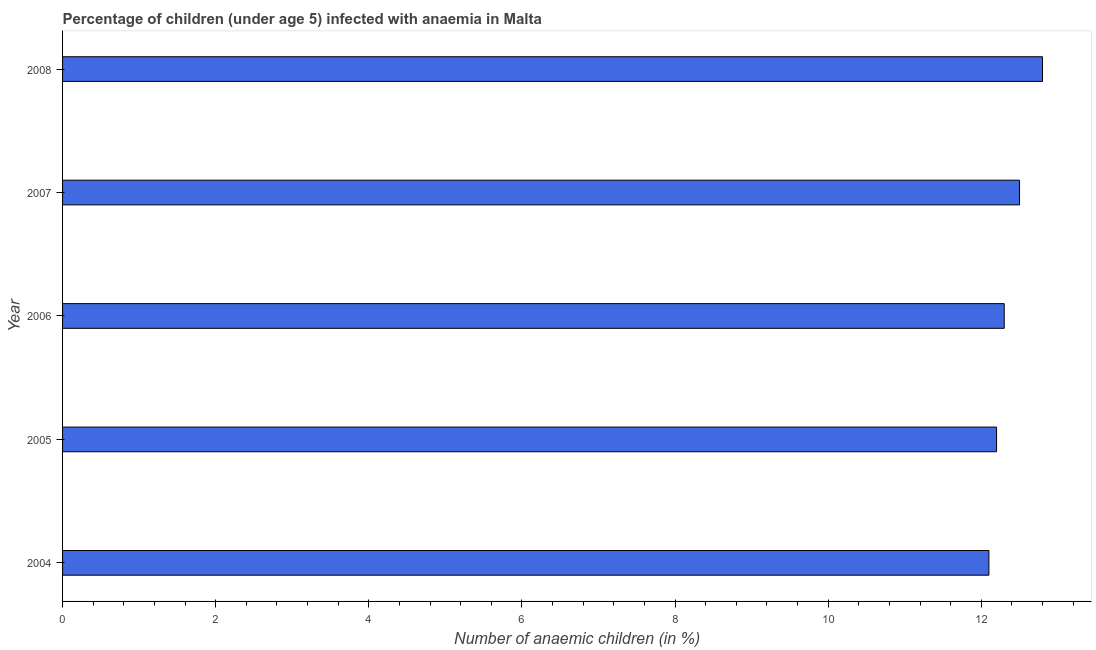What is the title of the graph?
Make the answer very short. Percentage of children (under age 5) infected with anaemia in Malta. What is the label or title of the X-axis?
Ensure brevity in your answer.  Number of anaemic children (in %). Across all years, what is the minimum number of anaemic children?
Offer a terse response. 12.1. In which year was the number of anaemic children maximum?
Provide a short and direct response. 2008. What is the sum of the number of anaemic children?
Keep it short and to the point. 61.9. What is the difference between the number of anaemic children in 2007 and 2008?
Provide a succinct answer. -0.3. What is the average number of anaemic children per year?
Offer a terse response. 12.38. In how many years, is the number of anaemic children greater than 1.2 %?
Give a very brief answer. 5. Do a majority of the years between 2008 and 2007 (inclusive) have number of anaemic children greater than 10.4 %?
Keep it short and to the point. No. What is the ratio of the number of anaemic children in 2005 to that in 2006?
Give a very brief answer. 0.99. What is the difference between the highest and the second highest number of anaemic children?
Give a very brief answer. 0.3. Are all the bars in the graph horizontal?
Your answer should be compact. Yes. What is the difference between two consecutive major ticks on the X-axis?
Your response must be concise. 2. What is the Number of anaemic children (in %) of 2005?
Give a very brief answer. 12.2. What is the Number of anaemic children (in %) in 2007?
Give a very brief answer. 12.5. What is the Number of anaemic children (in %) in 2008?
Ensure brevity in your answer.  12.8. What is the difference between the Number of anaemic children (in %) in 2004 and 2005?
Give a very brief answer. -0.1. What is the difference between the Number of anaemic children (in %) in 2004 and 2008?
Your response must be concise. -0.7. What is the difference between the Number of anaemic children (in %) in 2005 and 2007?
Offer a very short reply. -0.3. What is the difference between the Number of anaemic children (in %) in 2006 and 2007?
Your answer should be compact. -0.2. What is the difference between the Number of anaemic children (in %) in 2006 and 2008?
Your answer should be compact. -0.5. What is the ratio of the Number of anaemic children (in %) in 2004 to that in 2005?
Keep it short and to the point. 0.99. What is the ratio of the Number of anaemic children (in %) in 2004 to that in 2006?
Your response must be concise. 0.98. What is the ratio of the Number of anaemic children (in %) in 2004 to that in 2008?
Provide a short and direct response. 0.94. What is the ratio of the Number of anaemic children (in %) in 2005 to that in 2008?
Your answer should be very brief. 0.95. What is the ratio of the Number of anaemic children (in %) in 2006 to that in 2007?
Your answer should be compact. 0.98. What is the ratio of the Number of anaemic children (in %) in 2007 to that in 2008?
Offer a very short reply. 0.98. 